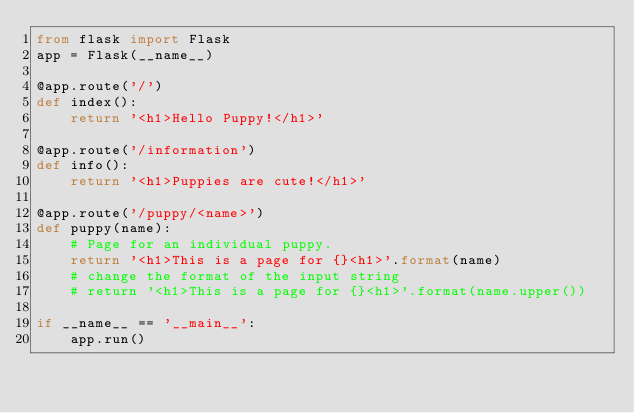Convert code to text. <code><loc_0><loc_0><loc_500><loc_500><_Python_>from flask import Flask
app = Flask(__name__)

@app.route('/')
def index():
    return '<h1>Hello Puppy!</h1>'

@app.route('/information')
def info():
    return '<h1>Puppies are cute!</h1>'

@app.route('/puppy/<name>')
def puppy(name):
    # Page for an individual puppy.
    return '<h1>This is a page for {}<h1>'.format(name)
    # change the format of the input string
    # return '<h1>This is a page for {}<h1>'.format(name.upper())

if __name__ == '__main__':
    app.run()
</code> 